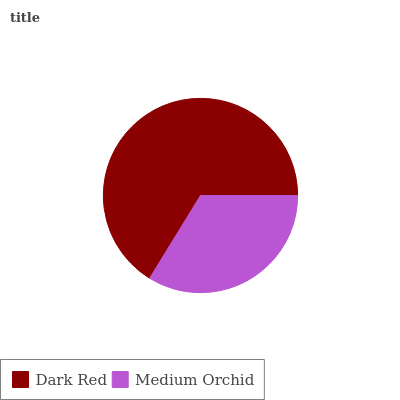Is Medium Orchid the minimum?
Answer yes or no. Yes. Is Dark Red the maximum?
Answer yes or no. Yes. Is Medium Orchid the maximum?
Answer yes or no. No. Is Dark Red greater than Medium Orchid?
Answer yes or no. Yes. Is Medium Orchid less than Dark Red?
Answer yes or no. Yes. Is Medium Orchid greater than Dark Red?
Answer yes or no. No. Is Dark Red less than Medium Orchid?
Answer yes or no. No. Is Dark Red the high median?
Answer yes or no. Yes. Is Medium Orchid the low median?
Answer yes or no. Yes. Is Medium Orchid the high median?
Answer yes or no. No. Is Dark Red the low median?
Answer yes or no. No. 